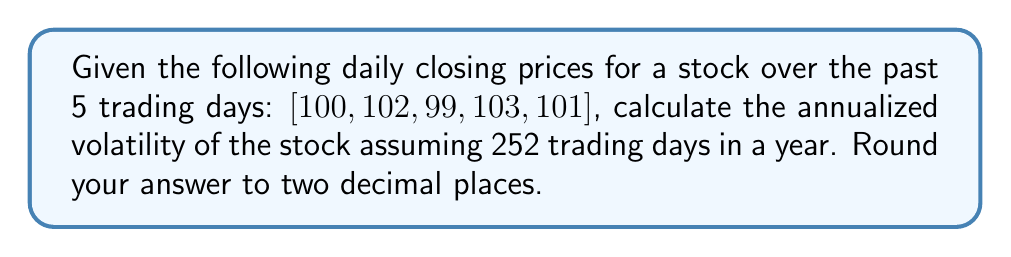Show me your answer to this math problem. To estimate the volatility of a stock using historical price data, we'll follow these steps:

1. Calculate daily returns:
   $R_t = \ln(\frac{P_t}{P_{t-1}})$
   where $R_t$ is the return on day $t$, and $P_t$ is the price on day $t$.

   $R_1 = \ln(\frac{102}{100}) = 0.01980$
   $R_2 = \ln(\frac{99}{102}) = -0.02999$
   $R_3 = \ln(\frac{103}{99}) = 0.03961$
   $R_4 = \ln(\frac{101}{103}) = -0.01970$

2. Calculate the mean of daily returns:
   $\bar{R} = \frac{1}{n}\sum_{t=1}^n R_t$
   $\bar{R} = \frac{0.01980 + (-0.02999) + 0.03961 + (-0.01970)}{4} = 0.00243$

3. Calculate the variance of daily returns:
   $\sigma^2 = \frac{1}{n-1}\sum_{t=1}^n (R_t - \bar{R})^2$
   $\sigma^2 = \frac{1}{3}[(0.01980 - 0.00243)^2 + (-0.02999 - 0.00243)^2 + (0.03961 - 0.00243)^2 + (-0.01970 - 0.00243)^2]$
   $\sigma^2 = 0.00103$

4. Calculate the standard deviation (daily volatility):
   $\sigma = \sqrt{\sigma^2} = \sqrt{0.00103} = 0.03209$

5. Annualize the volatility:
   $\sigma_{annual} = \sigma \times \sqrt{252}$
   $\sigma_{annual} = 0.03209 \times \sqrt{252} = 0.5094$

6. Convert to percentage and round to two decimal places:
   $\sigma_{annual} = 50.94\%$
Answer: The annualized volatility of the stock is 50.94%. 